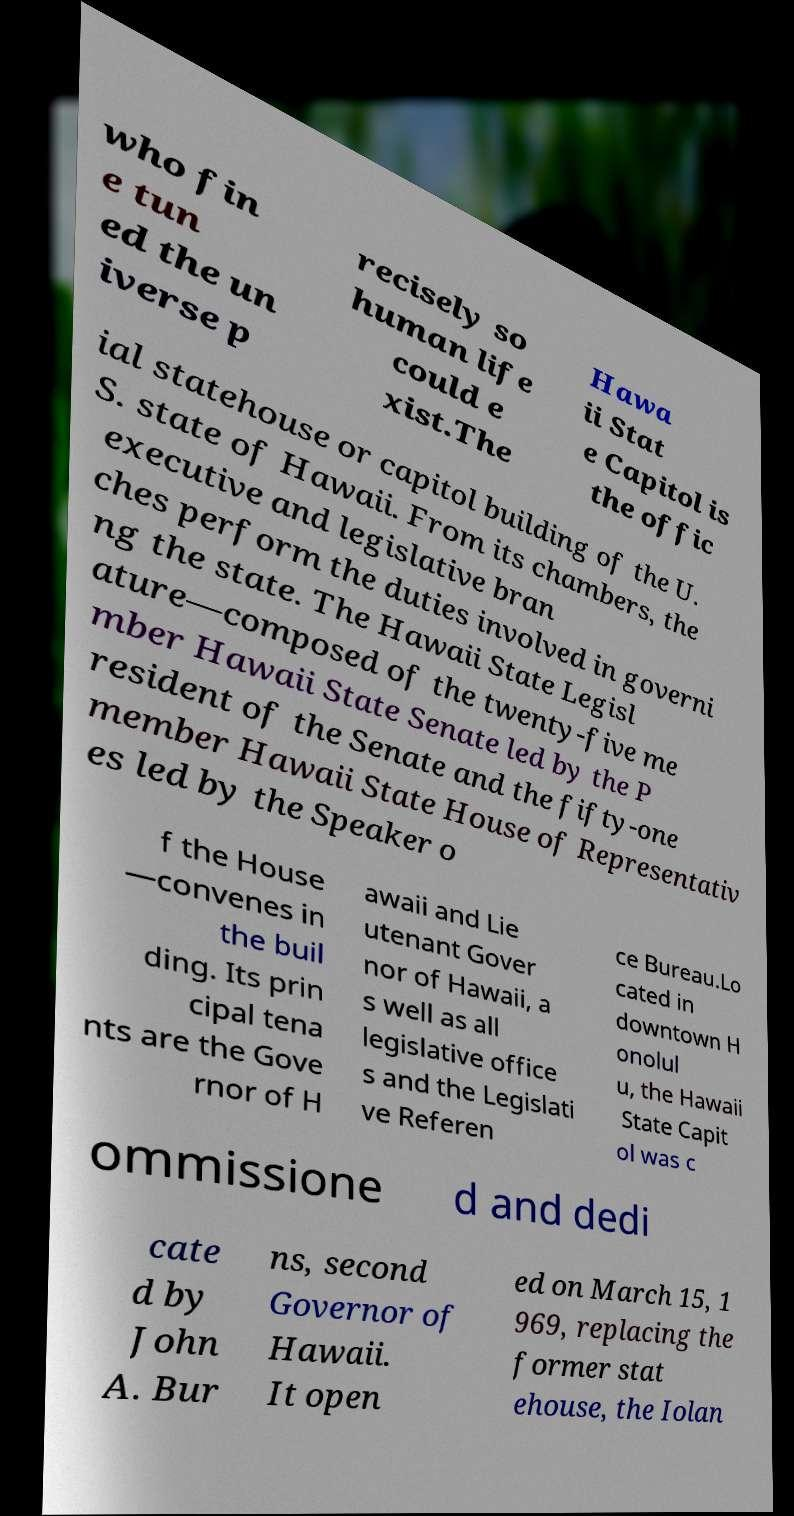Please read and relay the text visible in this image. What does it say? who fin e tun ed the un iverse p recisely so human life could e xist.The Hawa ii Stat e Capitol is the offic ial statehouse or capitol building of the U. S. state of Hawaii. From its chambers, the executive and legislative bran ches perform the duties involved in governi ng the state. The Hawaii State Legisl ature—composed of the twenty-five me mber Hawaii State Senate led by the P resident of the Senate and the fifty-one member Hawaii State House of Representativ es led by the Speaker o f the House —convenes in the buil ding. Its prin cipal tena nts are the Gove rnor of H awaii and Lie utenant Gover nor of Hawaii, a s well as all legislative office s and the Legislati ve Referen ce Bureau.Lo cated in downtown H onolul u, the Hawaii State Capit ol was c ommissione d and dedi cate d by John A. Bur ns, second Governor of Hawaii. It open ed on March 15, 1 969, replacing the former stat ehouse, the Iolan 